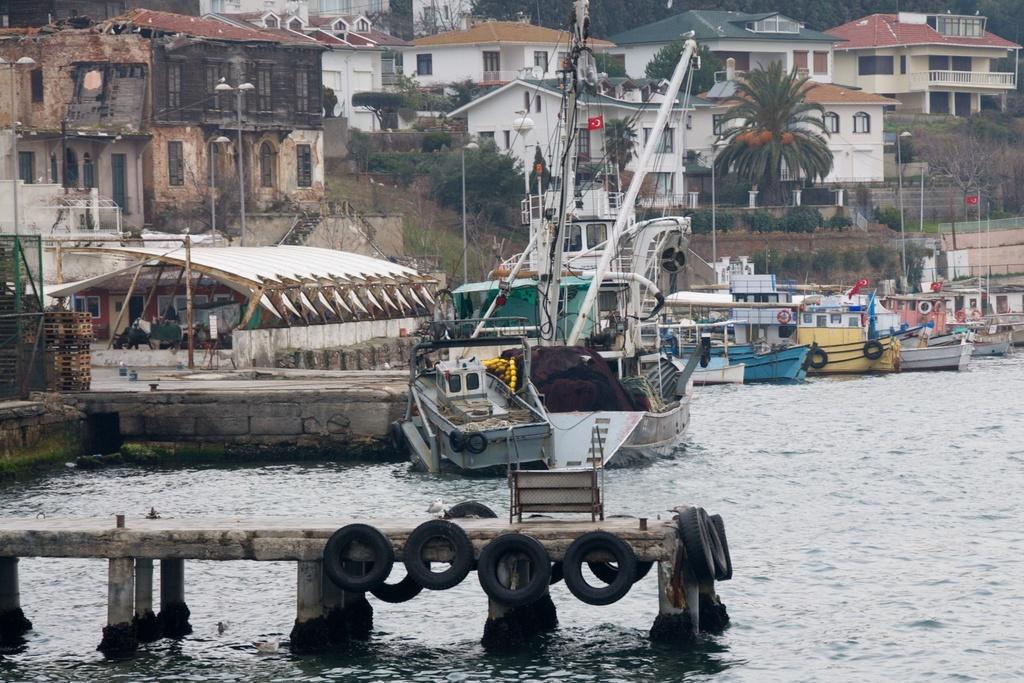What is at the bottom of the image? A: There is water at the bottom of the image. What can be seen above the water in the image? There are boats and ships above the water. What is located in the middle of the image? There are poles, trees, plants, and buildings in the middle of the image. Reasoning: Let's think step by step by step in order to produce the conversation. We start by identifying the main elements in the image, which include water at the bottom and boats and ships above the water. Then, we focus on the middle of the image, where there are various objects and structures, such as poles, trees, plants, and buildings. Each question is designed to elicit a specific detail about the image that is known from the provided facts. Absurd Question/Answer: Can you see any celery growing in the middle of the image? There is no celery present in the image. Is there a mountain visible in the image? There is no mountain visible in the image. Can you see any celery growing in the middle of the image? There is no celery present in the image. Is there a mountain visible in the image? There is no mountain visible in the image. 